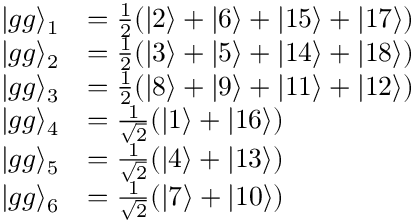Convert formula to latex. <formula><loc_0><loc_0><loc_500><loc_500>\begin{array} { r l } { | g g \rangle _ { 1 } } & { = \frac { 1 } { 2 } ( | 2 \rangle + | 6 \rangle + | 1 5 \rangle + | 1 7 \rangle ) } \\ { | g g \rangle _ { 2 } } & { = \frac { 1 } { 2 } ( | 3 \rangle + | 5 \rangle + | 1 4 \rangle + | 1 8 \rangle ) } \\ { | g g \rangle _ { 3 } } & { = \frac { 1 } { 2 } ( | 8 \rangle + | 9 \rangle + | 1 1 \rangle + | 1 2 \rangle ) } \\ { | g g \rangle _ { 4 } } & { = \frac { 1 } { \sqrt { 2 } } ( | 1 \rangle + | 1 6 \rangle ) } \\ { | g g \rangle _ { 5 } } & { = \frac { 1 } { \sqrt { 2 } } ( | 4 \rangle + | 1 3 \rangle ) } \\ { | g g \rangle _ { 6 } } & { = \frac { 1 } { \sqrt { 2 } } ( | 7 \rangle + | 1 0 \rangle ) } \end{array}</formula> 